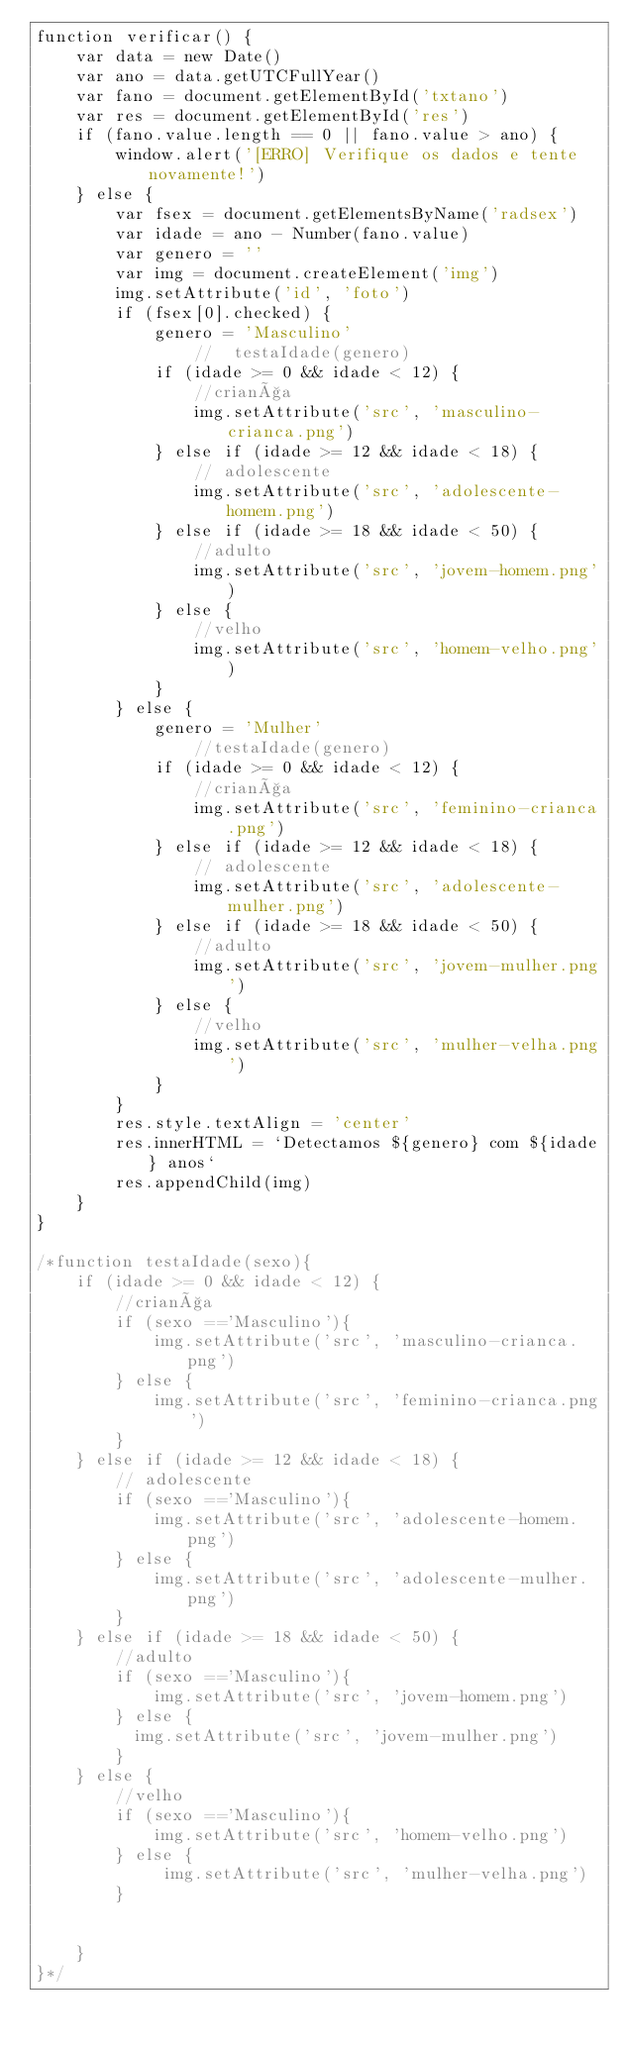Convert code to text. <code><loc_0><loc_0><loc_500><loc_500><_JavaScript_>function verificar() {
    var data = new Date()
    var ano = data.getUTCFullYear()
    var fano = document.getElementById('txtano')
    var res = document.getElementById('res')
    if (fano.value.length == 0 || fano.value > ano) {
        window.alert('[ERRO] Verifique os dados e tente novamente!')
    } else {
        var fsex = document.getElementsByName('radsex')
        var idade = ano - Number(fano.value)
        var genero = ''
        var img = document.createElement('img')
        img.setAttribute('id', 'foto')
        if (fsex[0].checked) {
            genero = 'Masculino'
                //  testaIdade(genero)
            if (idade >= 0 && idade < 12) {
                //criança
                img.setAttribute('src', 'masculino-crianca.png')
            } else if (idade >= 12 && idade < 18) {
                // adolescente
                img.setAttribute('src', 'adolescente-homem.png')
            } else if (idade >= 18 && idade < 50) {
                //adulto
                img.setAttribute('src', 'jovem-homem.png')
            } else {
                //velho
                img.setAttribute('src', 'homem-velho.png')
            }
        } else {
            genero = 'Mulher'
                //testaIdade(genero)
            if (idade >= 0 && idade < 12) {
                //criança
                img.setAttribute('src', 'feminino-crianca.png')
            } else if (idade >= 12 && idade < 18) {
                // adolescente
                img.setAttribute('src', 'adolescente-mulher.png')
            } else if (idade >= 18 && idade < 50) {
                //adulto
                img.setAttribute('src', 'jovem-mulher.png')
            } else {
                //velho
                img.setAttribute('src', 'mulher-velha.png')
            }
        }
        res.style.textAlign = 'center'
        res.innerHTML = `Detectamos ${genero} com ${idade} anos`
        res.appendChild(img)
    }
}

/*function testaIdade(sexo){
    if (idade >= 0 && idade < 12) {
        //criança
        if (sexo =='Masculino'){
            img.setAttribute('src', 'masculino-crianca.png')
        } else {
            img.setAttribute('src', 'feminino-crianca.png')
        }
    } else if (idade >= 12 && idade < 18) {
        // adolescente
        if (sexo =='Masculino'){
            img.setAttribute('src', 'adolescente-homem.png')
        } else {
            img.setAttribute('src', 'adolescente-mulher.png')
        }
    } else if (idade >= 18 && idade < 50) {
        //adulto
        if (sexo =='Masculino'){
            img.setAttribute('src', 'jovem-homem.png')
        } else {
          img.setAttribute('src', 'jovem-mulher.png')  
        }
    } else {
        //velho
        if (sexo =='Masculino'){
            img.setAttribute('src', 'homem-velho.png')
        } else {
             img.setAttribute('src', 'mulher-velha.png')
        }
        
       
    }
}*/</code> 